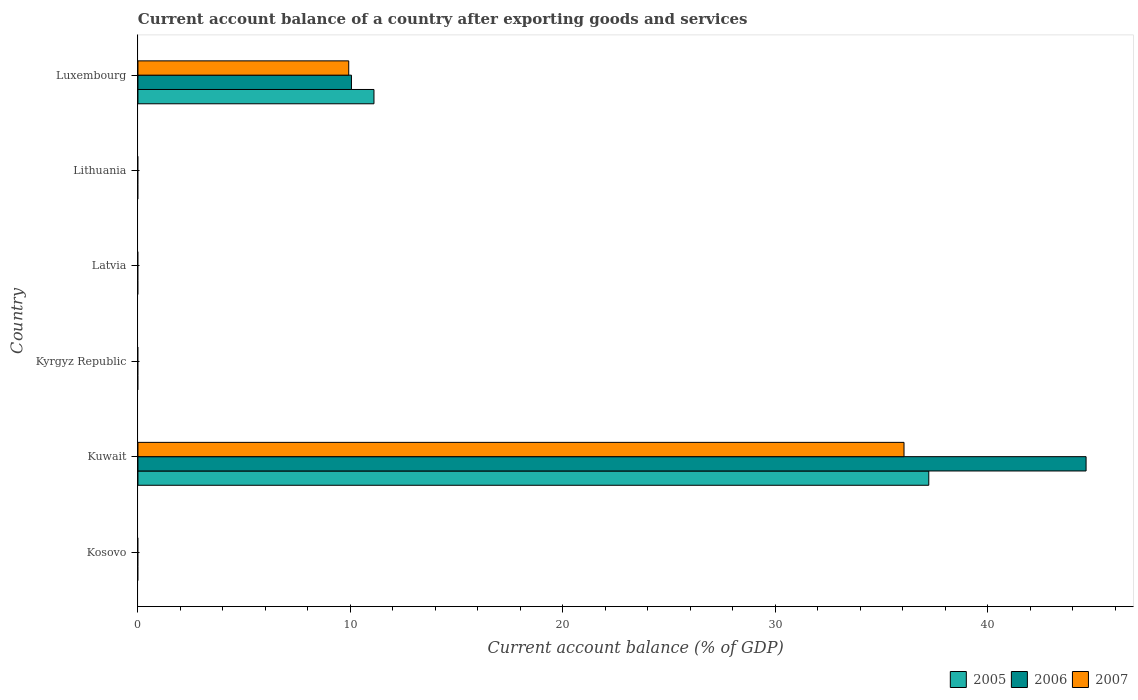Are the number of bars per tick equal to the number of legend labels?
Offer a very short reply. No. How many bars are there on the 5th tick from the bottom?
Provide a short and direct response. 0. What is the label of the 5th group of bars from the top?
Make the answer very short. Kuwait. In how many cases, is the number of bars for a given country not equal to the number of legend labels?
Make the answer very short. 4. What is the account balance in 2007 in Kyrgyz Republic?
Your answer should be compact. 0. Across all countries, what is the maximum account balance in 2005?
Your answer should be very brief. 37.22. In which country was the account balance in 2005 maximum?
Your answer should be very brief. Kuwait. What is the total account balance in 2007 in the graph?
Your response must be concise. 45.97. What is the difference between the account balance in 2005 in Kuwait and that in Luxembourg?
Offer a terse response. 26.11. What is the average account balance in 2007 per country?
Your answer should be very brief. 7.66. What is the difference between the account balance in 2005 and account balance in 2007 in Luxembourg?
Your response must be concise. 1.19. In how many countries, is the account balance in 2007 greater than 28 %?
Make the answer very short. 1. What is the difference between the highest and the lowest account balance in 2005?
Provide a short and direct response. 37.22. In how many countries, is the account balance in 2005 greater than the average account balance in 2005 taken over all countries?
Your answer should be very brief. 2. Are all the bars in the graph horizontal?
Keep it short and to the point. Yes. How many countries are there in the graph?
Give a very brief answer. 6. What is the difference between two consecutive major ticks on the X-axis?
Your answer should be compact. 10. Are the values on the major ticks of X-axis written in scientific E-notation?
Ensure brevity in your answer.  No. Does the graph contain grids?
Offer a very short reply. No. How many legend labels are there?
Ensure brevity in your answer.  3. What is the title of the graph?
Ensure brevity in your answer.  Current account balance of a country after exporting goods and services. What is the label or title of the X-axis?
Your answer should be compact. Current account balance (% of GDP). What is the Current account balance (% of GDP) in 2005 in Kosovo?
Make the answer very short. 0. What is the Current account balance (% of GDP) of 2007 in Kosovo?
Your response must be concise. 0. What is the Current account balance (% of GDP) of 2005 in Kuwait?
Offer a very short reply. 37.22. What is the Current account balance (% of GDP) in 2006 in Kuwait?
Offer a terse response. 44.62. What is the Current account balance (% of GDP) of 2007 in Kuwait?
Your response must be concise. 36.05. What is the Current account balance (% of GDP) of 2006 in Kyrgyz Republic?
Make the answer very short. 0. What is the Current account balance (% of GDP) of 2007 in Kyrgyz Republic?
Keep it short and to the point. 0. What is the Current account balance (% of GDP) in 2005 in Latvia?
Give a very brief answer. 0. What is the Current account balance (% of GDP) in 2006 in Latvia?
Offer a very short reply. 0. What is the Current account balance (% of GDP) in 2005 in Lithuania?
Offer a terse response. 0. What is the Current account balance (% of GDP) in 2005 in Luxembourg?
Your response must be concise. 11.11. What is the Current account balance (% of GDP) in 2006 in Luxembourg?
Provide a succinct answer. 10.05. What is the Current account balance (% of GDP) of 2007 in Luxembourg?
Your answer should be very brief. 9.92. Across all countries, what is the maximum Current account balance (% of GDP) of 2005?
Provide a short and direct response. 37.22. Across all countries, what is the maximum Current account balance (% of GDP) in 2006?
Keep it short and to the point. 44.62. Across all countries, what is the maximum Current account balance (% of GDP) of 2007?
Provide a short and direct response. 36.05. Across all countries, what is the minimum Current account balance (% of GDP) of 2006?
Provide a short and direct response. 0. What is the total Current account balance (% of GDP) of 2005 in the graph?
Ensure brevity in your answer.  48.32. What is the total Current account balance (% of GDP) of 2006 in the graph?
Provide a short and direct response. 54.67. What is the total Current account balance (% of GDP) in 2007 in the graph?
Your answer should be very brief. 45.97. What is the difference between the Current account balance (% of GDP) in 2005 in Kuwait and that in Luxembourg?
Make the answer very short. 26.11. What is the difference between the Current account balance (% of GDP) in 2006 in Kuwait and that in Luxembourg?
Your answer should be compact. 34.57. What is the difference between the Current account balance (% of GDP) in 2007 in Kuwait and that in Luxembourg?
Ensure brevity in your answer.  26.13. What is the difference between the Current account balance (% of GDP) of 2005 in Kuwait and the Current account balance (% of GDP) of 2006 in Luxembourg?
Provide a short and direct response. 27.17. What is the difference between the Current account balance (% of GDP) in 2005 in Kuwait and the Current account balance (% of GDP) in 2007 in Luxembourg?
Your answer should be very brief. 27.3. What is the difference between the Current account balance (% of GDP) of 2006 in Kuwait and the Current account balance (% of GDP) of 2007 in Luxembourg?
Provide a succinct answer. 34.7. What is the average Current account balance (% of GDP) in 2005 per country?
Provide a succinct answer. 8.05. What is the average Current account balance (% of GDP) in 2006 per country?
Provide a short and direct response. 9.11. What is the average Current account balance (% of GDP) of 2007 per country?
Your response must be concise. 7.66. What is the difference between the Current account balance (% of GDP) of 2005 and Current account balance (% of GDP) of 2006 in Kuwait?
Offer a terse response. -7.4. What is the difference between the Current account balance (% of GDP) of 2005 and Current account balance (% of GDP) of 2007 in Kuwait?
Give a very brief answer. 1.17. What is the difference between the Current account balance (% of GDP) in 2006 and Current account balance (% of GDP) in 2007 in Kuwait?
Provide a succinct answer. 8.57. What is the difference between the Current account balance (% of GDP) in 2005 and Current account balance (% of GDP) in 2006 in Luxembourg?
Your answer should be compact. 1.06. What is the difference between the Current account balance (% of GDP) of 2005 and Current account balance (% of GDP) of 2007 in Luxembourg?
Your answer should be very brief. 1.19. What is the difference between the Current account balance (% of GDP) in 2006 and Current account balance (% of GDP) in 2007 in Luxembourg?
Your answer should be very brief. 0.13. What is the ratio of the Current account balance (% of GDP) of 2005 in Kuwait to that in Luxembourg?
Your answer should be compact. 3.35. What is the ratio of the Current account balance (% of GDP) of 2006 in Kuwait to that in Luxembourg?
Offer a very short reply. 4.44. What is the ratio of the Current account balance (% of GDP) of 2007 in Kuwait to that in Luxembourg?
Your answer should be compact. 3.63. What is the difference between the highest and the lowest Current account balance (% of GDP) in 2005?
Provide a succinct answer. 37.22. What is the difference between the highest and the lowest Current account balance (% of GDP) in 2006?
Offer a terse response. 44.62. What is the difference between the highest and the lowest Current account balance (% of GDP) in 2007?
Your response must be concise. 36.05. 